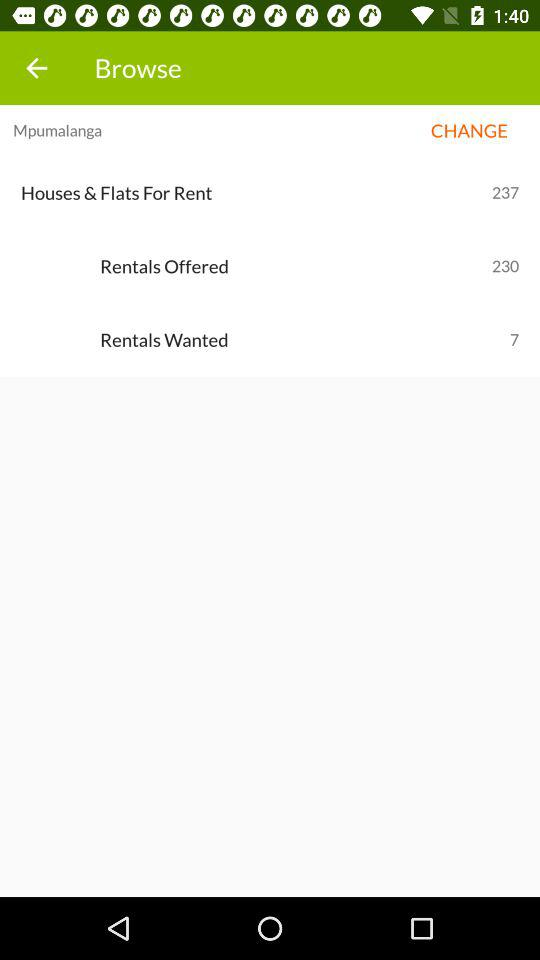How many "Houses & Flats For Rent" are there in "Rentals Wanted"? "Houses & Flats For Rent" are seven in "Rentals Wanted". 